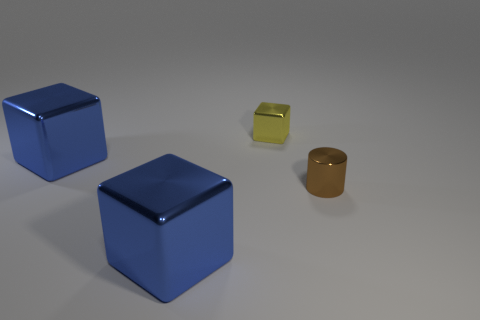Add 1 yellow metal objects. How many objects exist? 5 Subtract all blocks. How many objects are left? 1 Subtract 1 yellow cubes. How many objects are left? 3 Subtract all big blue objects. Subtract all big blue cubes. How many objects are left? 0 Add 2 small yellow metallic cubes. How many small yellow metallic cubes are left? 3 Add 3 big blocks. How many big blocks exist? 5 